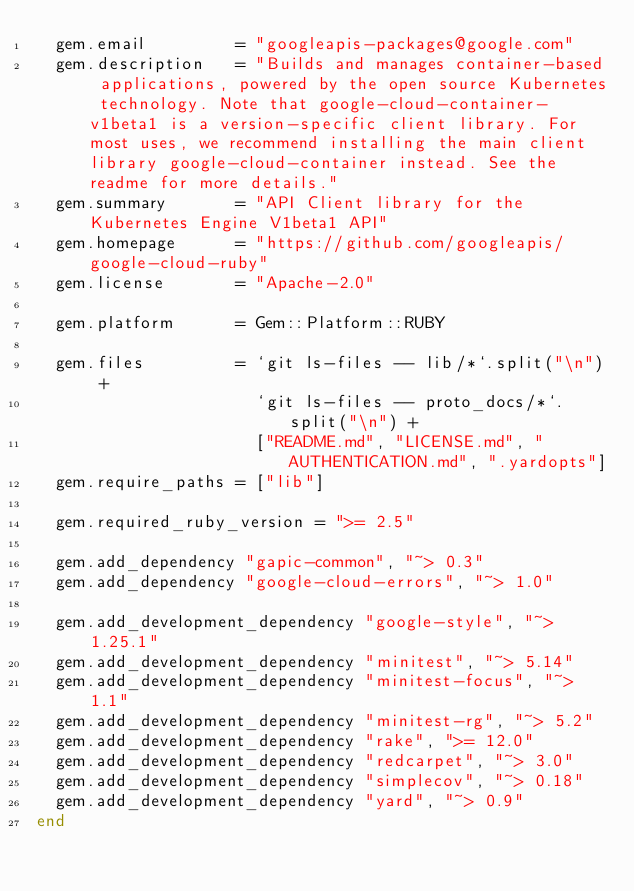Convert code to text. <code><loc_0><loc_0><loc_500><loc_500><_Ruby_>  gem.email         = "googleapis-packages@google.com"
  gem.description   = "Builds and manages container-based applications, powered by the open source Kubernetes technology. Note that google-cloud-container-v1beta1 is a version-specific client library. For most uses, we recommend installing the main client library google-cloud-container instead. See the readme for more details."
  gem.summary       = "API Client library for the Kubernetes Engine V1beta1 API"
  gem.homepage      = "https://github.com/googleapis/google-cloud-ruby"
  gem.license       = "Apache-2.0"

  gem.platform      = Gem::Platform::RUBY

  gem.files         = `git ls-files -- lib/*`.split("\n") +
                      `git ls-files -- proto_docs/*`.split("\n") +
                      ["README.md", "LICENSE.md", "AUTHENTICATION.md", ".yardopts"]
  gem.require_paths = ["lib"]

  gem.required_ruby_version = ">= 2.5"

  gem.add_dependency "gapic-common", "~> 0.3"
  gem.add_dependency "google-cloud-errors", "~> 1.0"

  gem.add_development_dependency "google-style", "~> 1.25.1"
  gem.add_development_dependency "minitest", "~> 5.14"
  gem.add_development_dependency "minitest-focus", "~> 1.1"
  gem.add_development_dependency "minitest-rg", "~> 5.2"
  gem.add_development_dependency "rake", ">= 12.0"
  gem.add_development_dependency "redcarpet", "~> 3.0"
  gem.add_development_dependency "simplecov", "~> 0.18"
  gem.add_development_dependency "yard", "~> 0.9"
end
</code> 